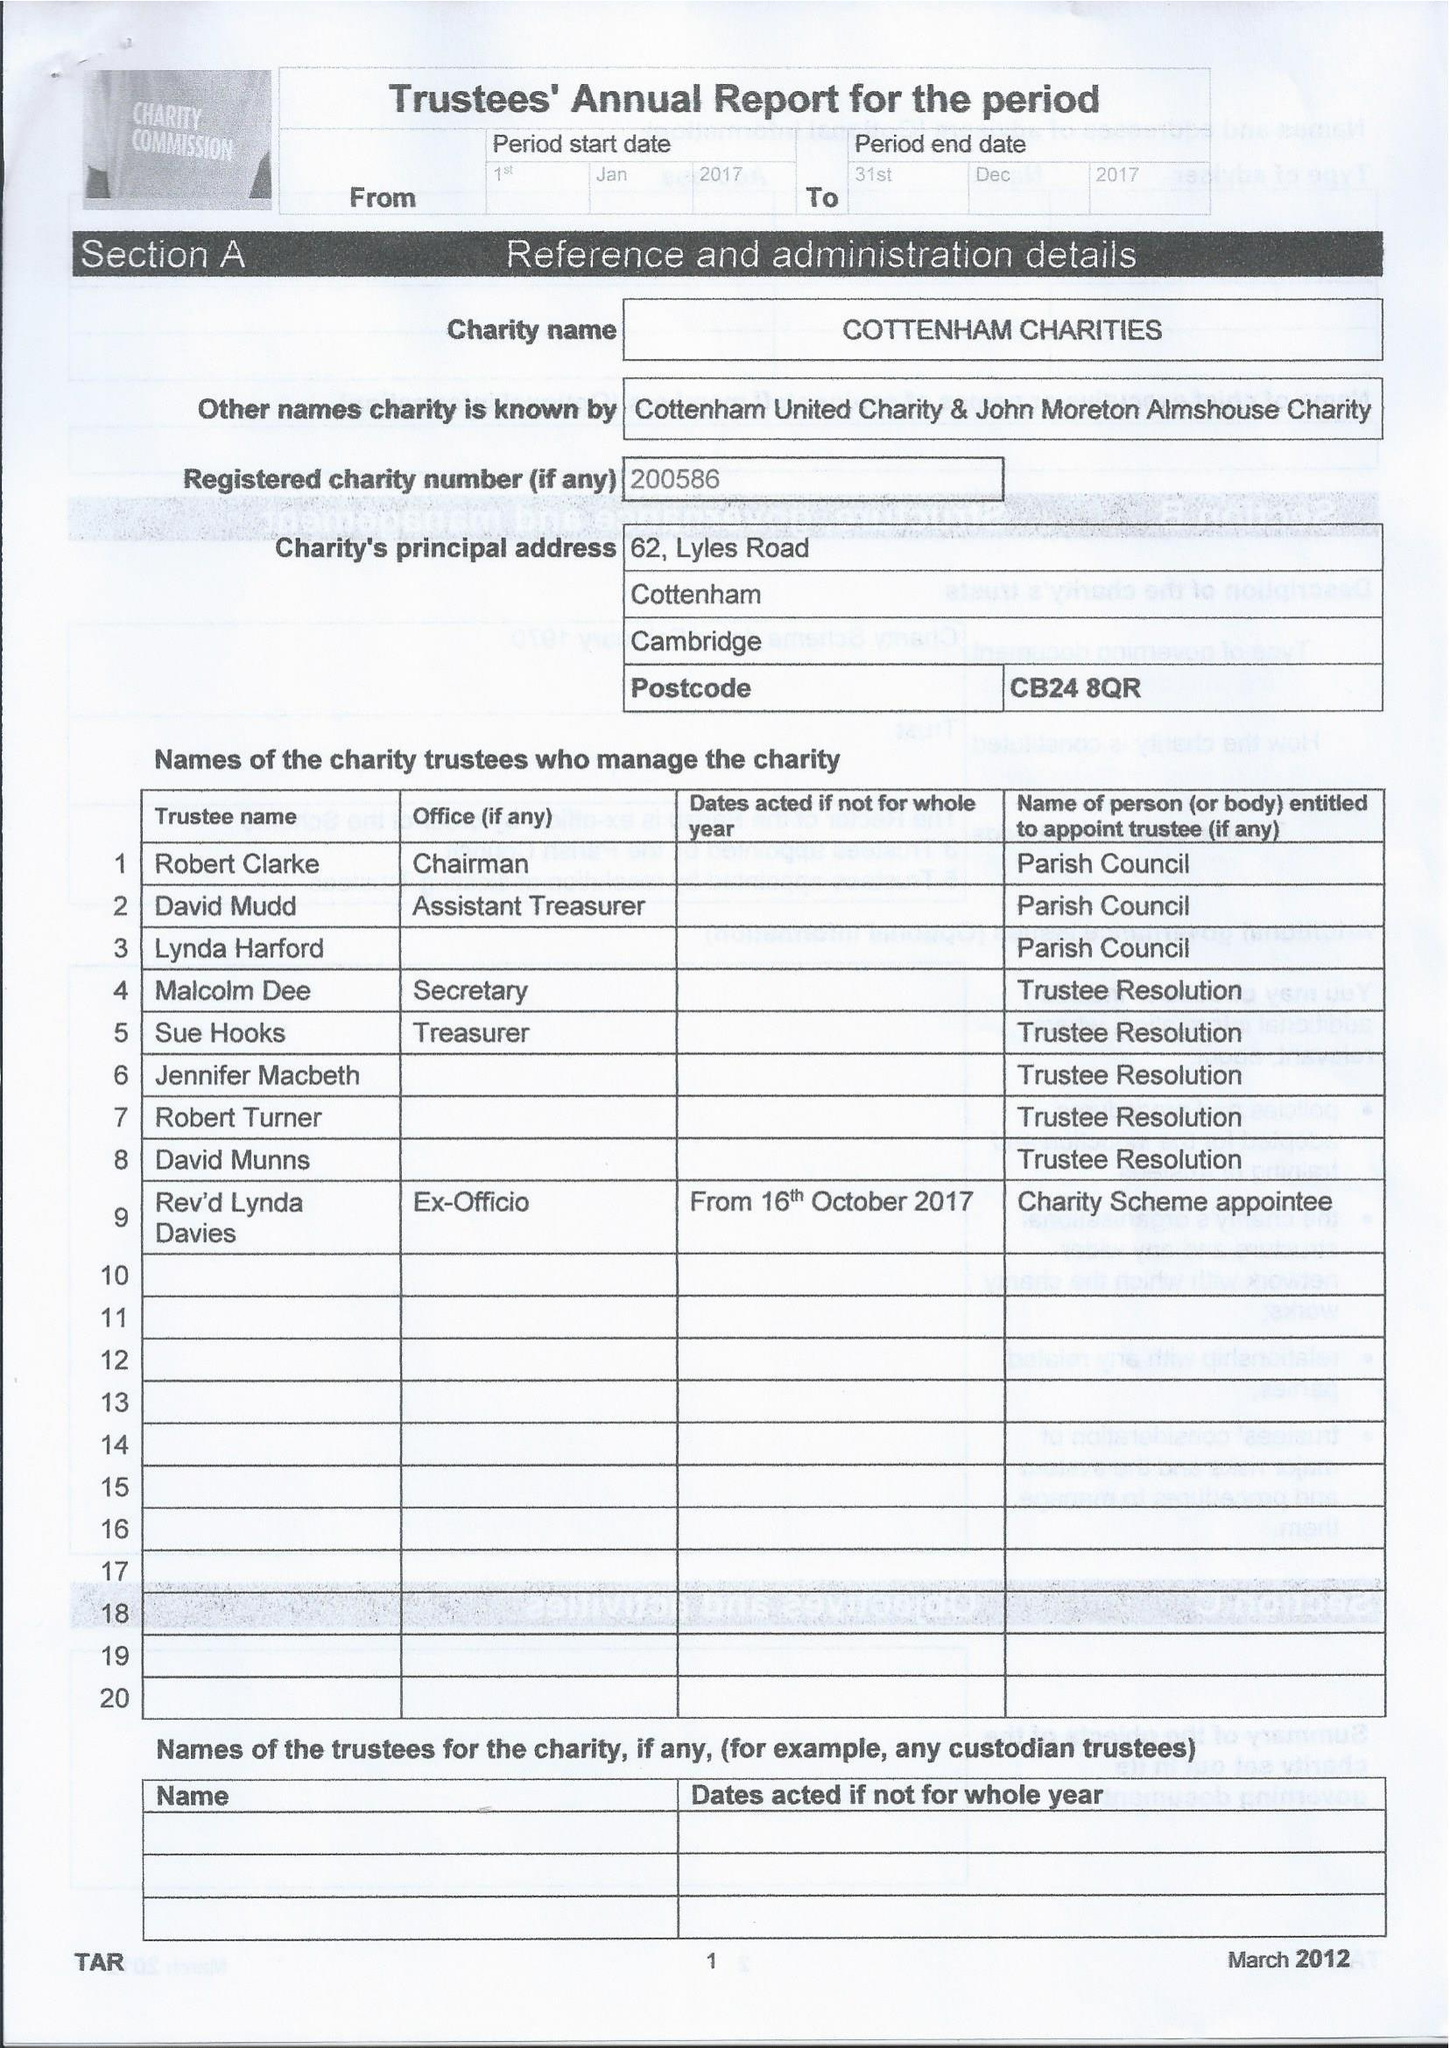What is the value for the charity_number?
Answer the question using a single word or phrase. 200586 